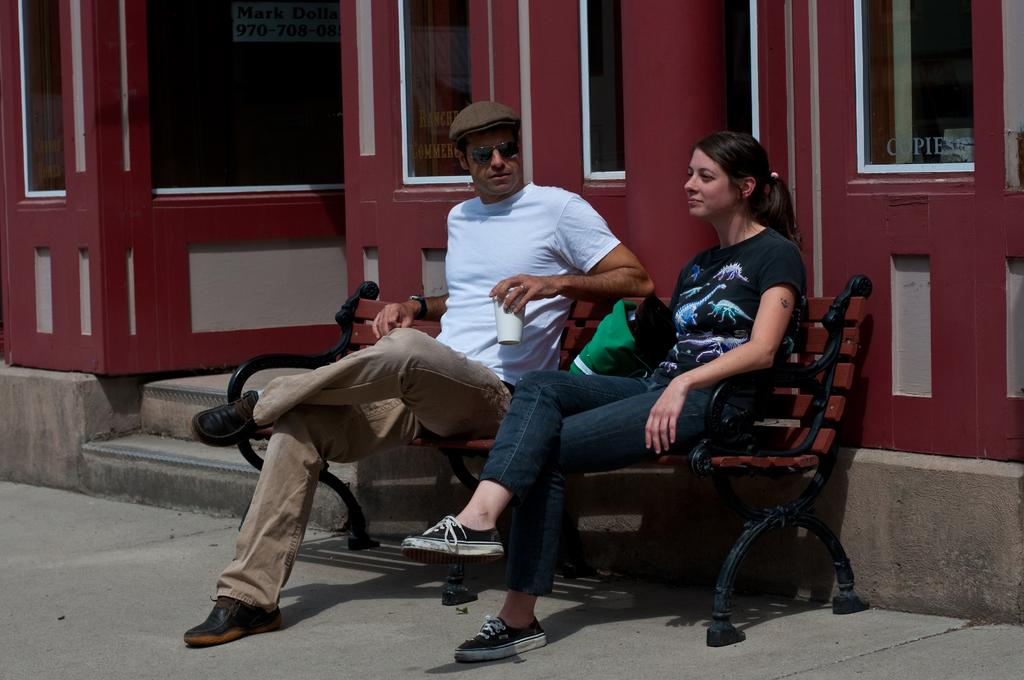How many people are sitting on the bench in the image? There are 2 people sitting on the bench in the image. Can you describe the clothing of one of the people? One person is wearing a cap and a white t-shirt. What is the person holding? The person is holding a glass. What can be seen behind the bench? There is a building behind the bench. What architectural feature is present on the building? The building has stairs. What type of lumber is being used to construct the town in the image? There is no town present in the image, and therefore no lumber can be observed. How many eggs are visible on the bench in the image? There are no eggs visible on the bench in the image. 